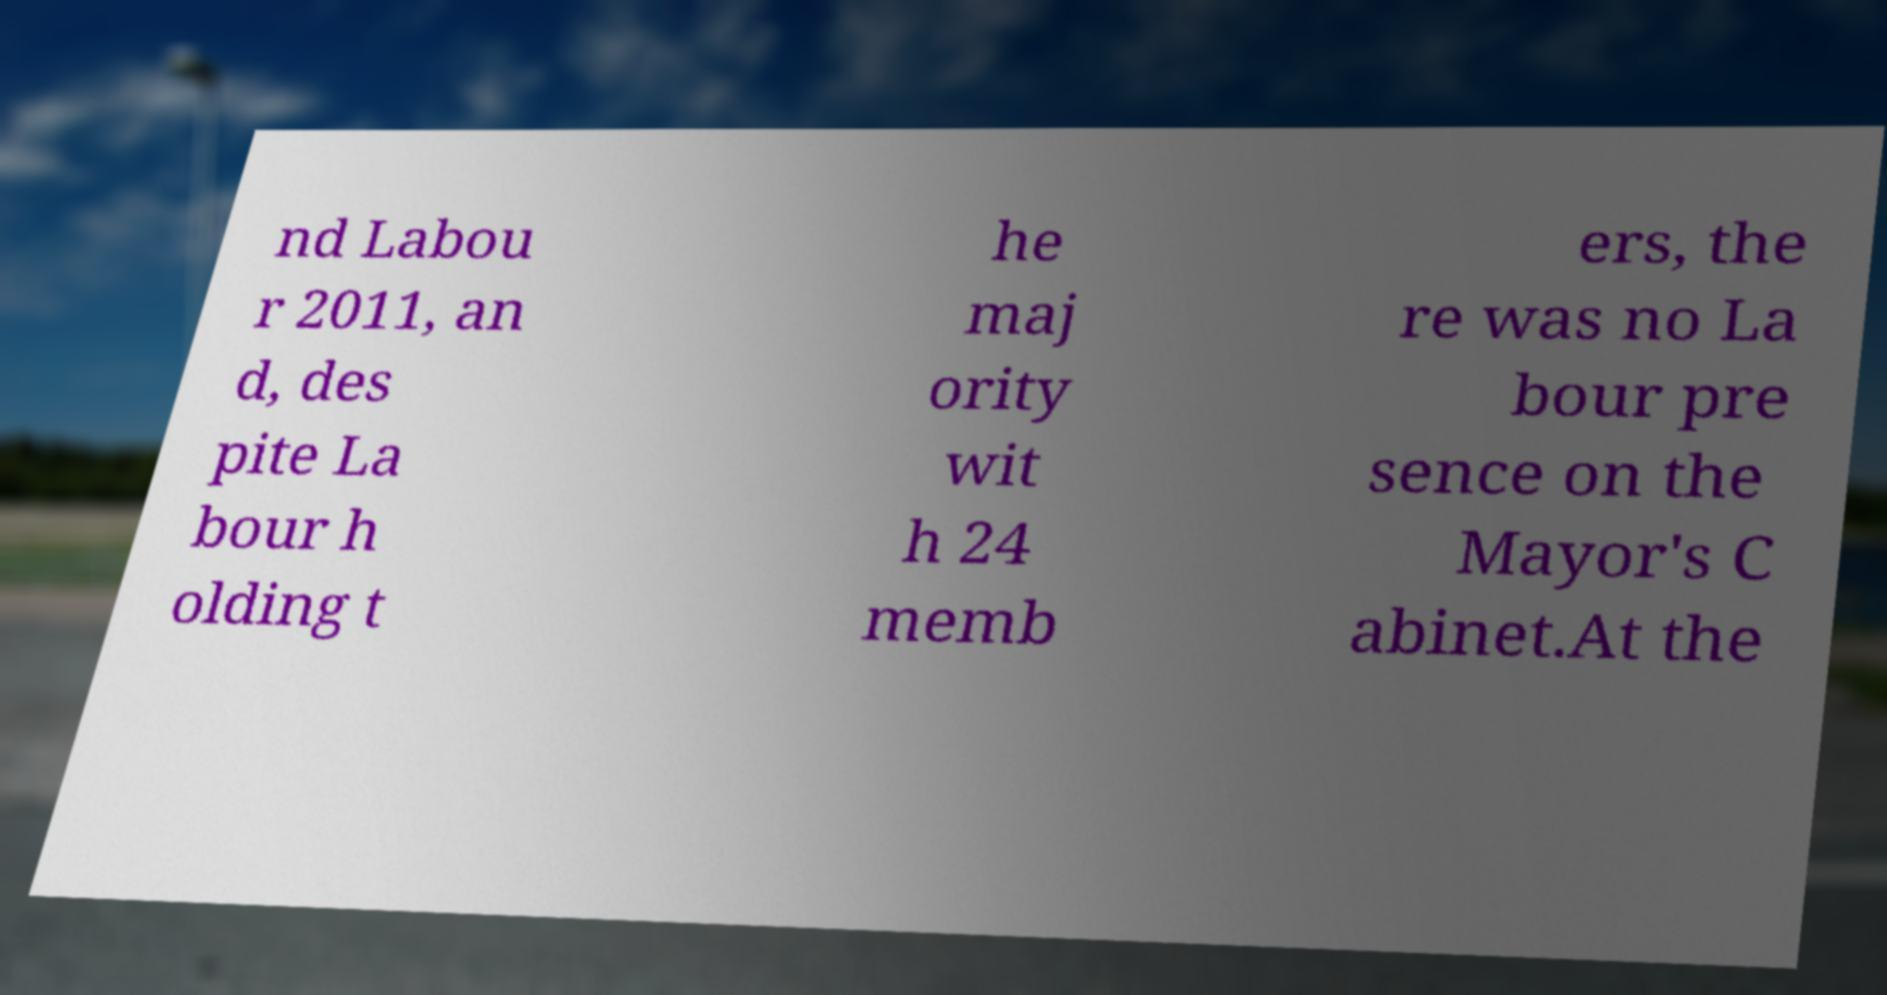Could you extract and type out the text from this image? nd Labou r 2011, an d, des pite La bour h olding t he maj ority wit h 24 memb ers, the re was no La bour pre sence on the Mayor's C abinet.At the 